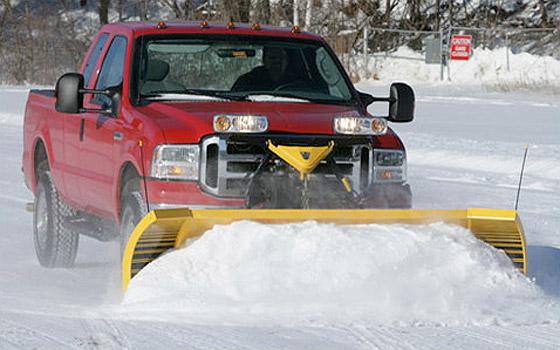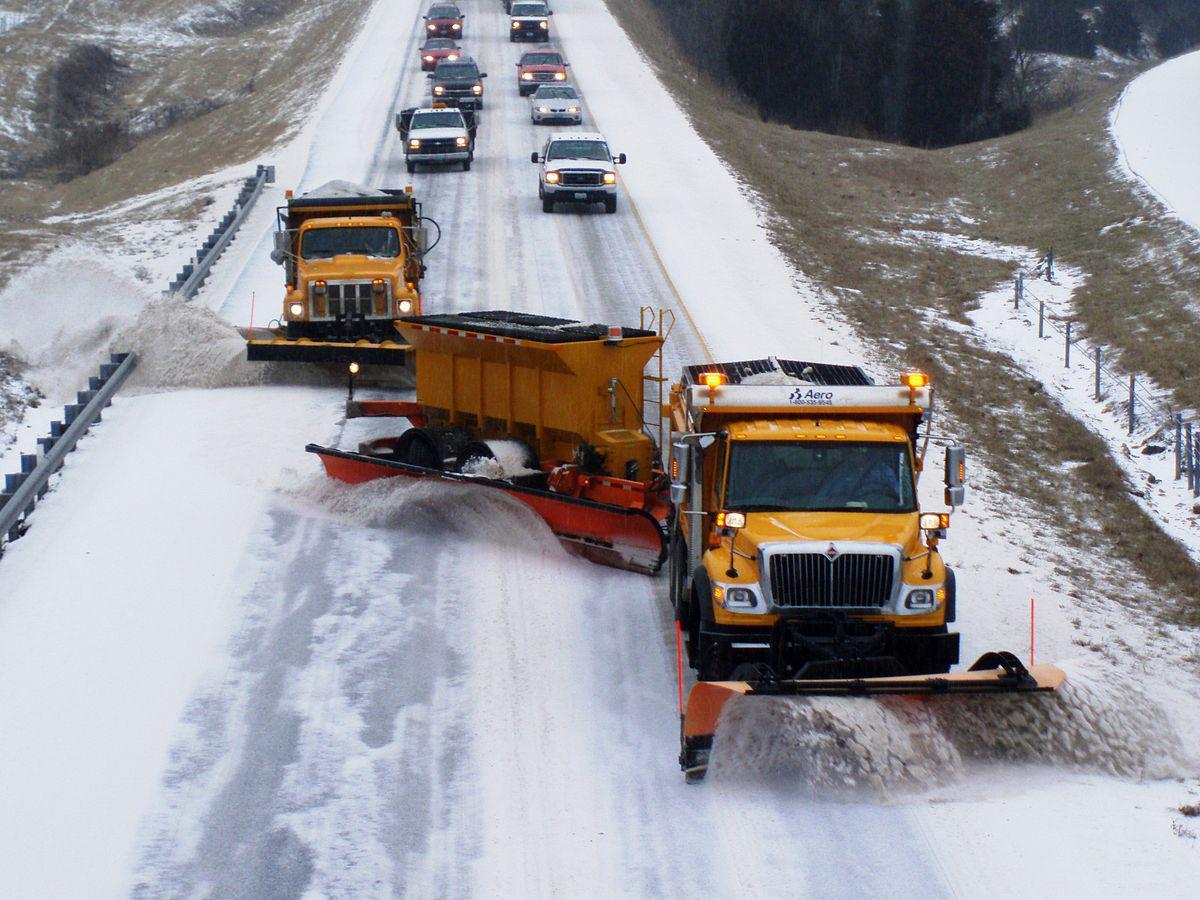The first image is the image on the left, the second image is the image on the right. For the images shown, is this caption "There are at most 3 trucks total." true? Answer yes or no. No. 